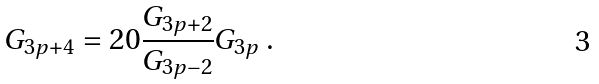<formula> <loc_0><loc_0><loc_500><loc_500>G _ { 3 p + 4 } = 2 0 \frac { G _ { 3 p + 2 } } { G _ { 3 p - 2 } } G _ { 3 p } \text { .}</formula> 